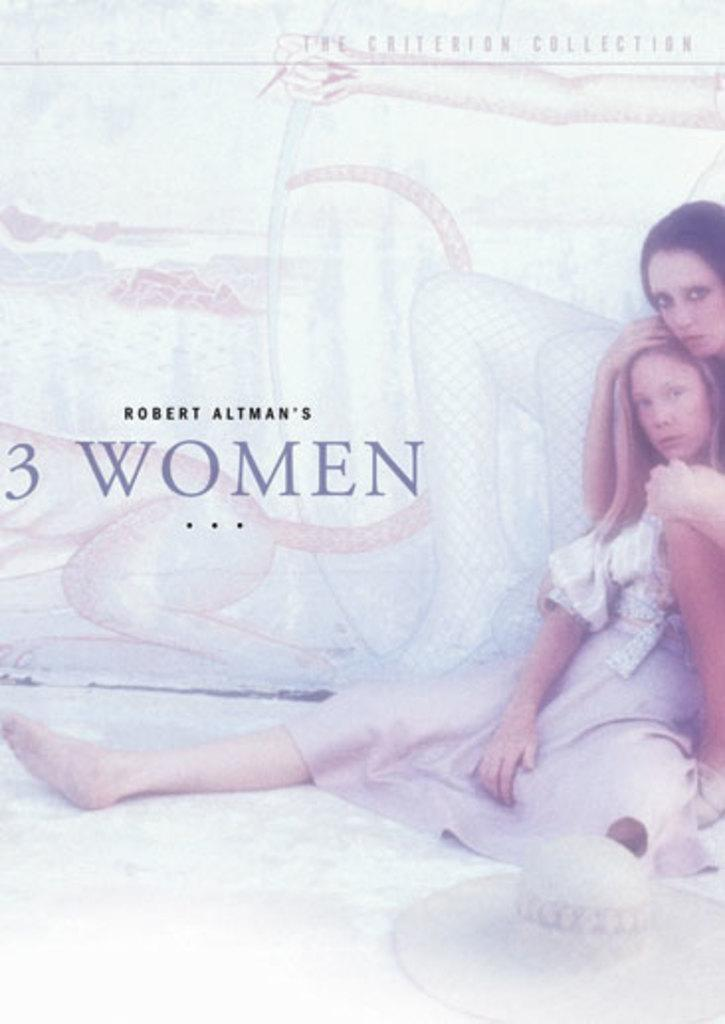What is featured in the image? There is a poster in the image. What type of images are on the poster? The poster contains images of women. What accessory is visible on the images of the women? There is a hat visible on the poster. What else is present on the poster besides the images? There is text present on the poster. What language are the women on the poster speaking? The image does not provide any information about the language spoken by the women on the poster. What type of curve can be seen on the poster? There is no curve present on the poster; it features images of women, a hat, and text. 